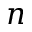<formula> <loc_0><loc_0><loc_500><loc_500>n</formula> 